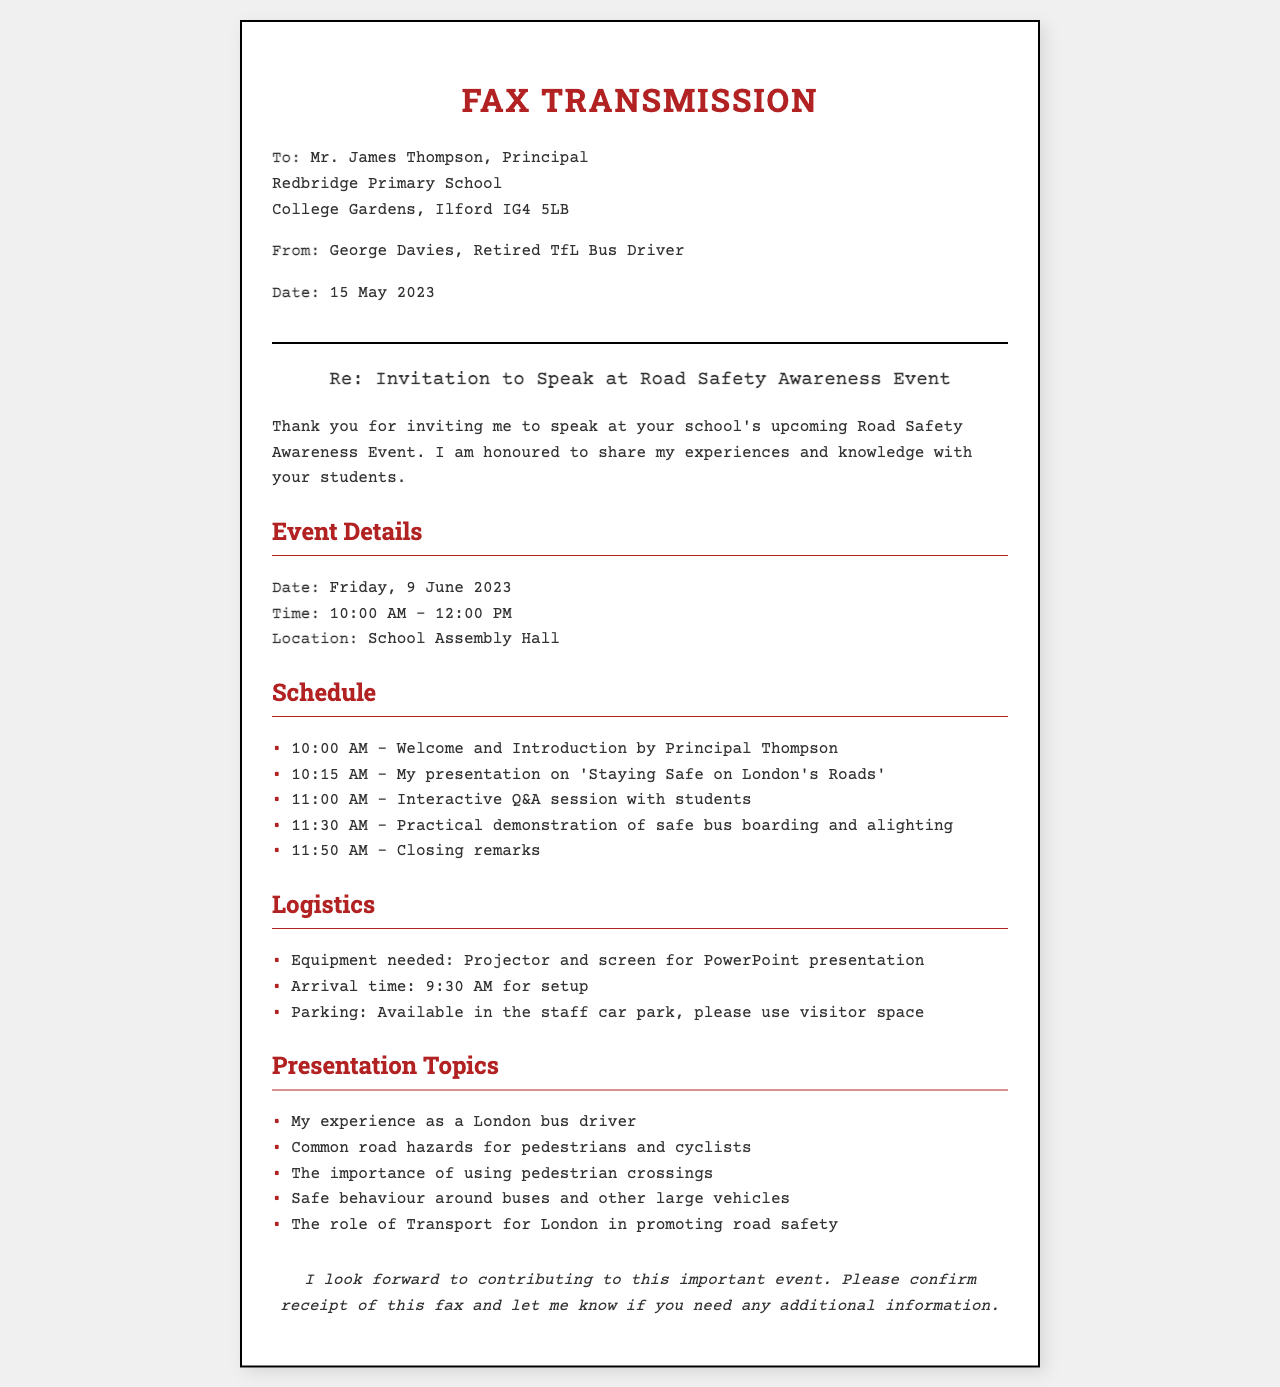What is the name of the principal? The principal's name is mentioned in the document as Mr. James Thompson.
Answer: Mr. James Thompson What is the date of the event? The event is scheduled for Friday, 9 June 2023.
Answer: Friday, 9 June 2023 What time does the event start? The starting time for the event is provided as 10:00 AM.
Answer: 10:00 AM What equipment is needed for the presentation? The document specifies that a projector and screen are needed for the presentation.
Answer: Projector and screen When should the speaker arrive for setup? The arrival time for setup is indicated as 9:30 AM.
Answer: 9:30 AM What is the topic of the speaker's presentation? The document mentions the presentation topic as 'Staying Safe on London's Roads'.
Answer: 'Staying Safe on London's Roads' Which session follows the introduction? The schedule lists the session after the introduction as the speaker's presentation.
Answer: Speaker's presentation How long is the interactive Q&A session? The interactive Q&A session is scheduled to last for 30 minutes, as indicated in the schedule.
Answer: 30 minutes What is the focus of the practical demonstration? The practical demonstration is focused on safe bus boarding and alighting.
Answer: Safe bus boarding and alighting 